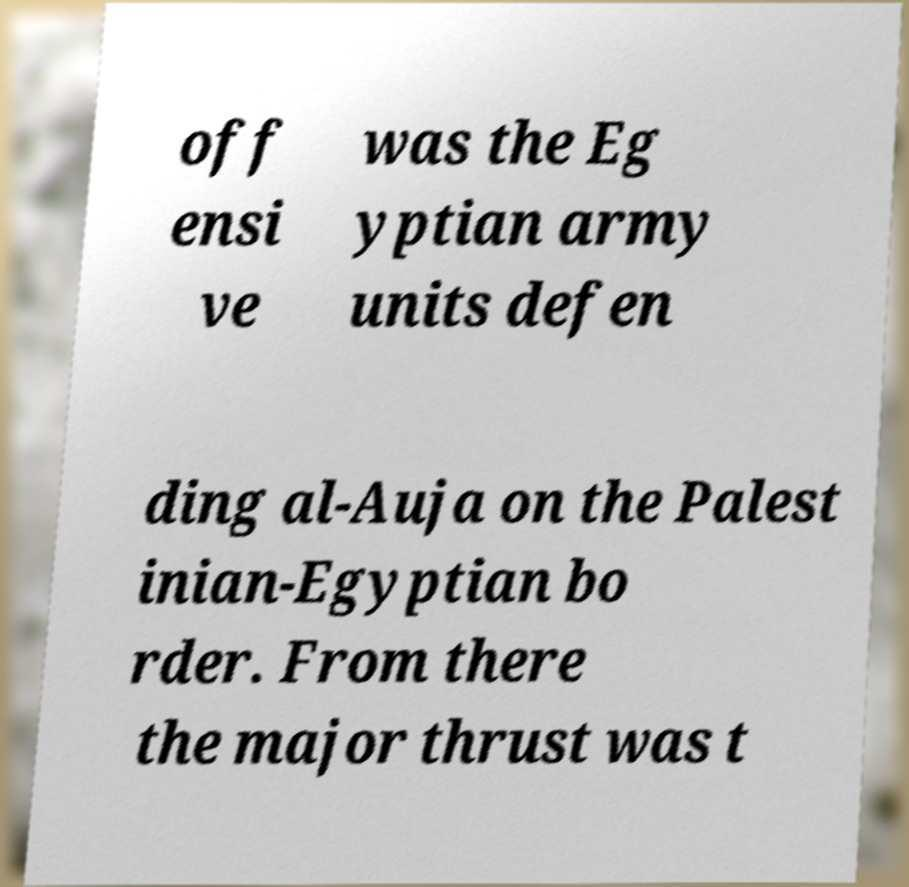Can you read and provide the text displayed in the image?This photo seems to have some interesting text. Can you extract and type it out for me? off ensi ve was the Eg yptian army units defen ding al-Auja on the Palest inian-Egyptian bo rder. From there the major thrust was t 